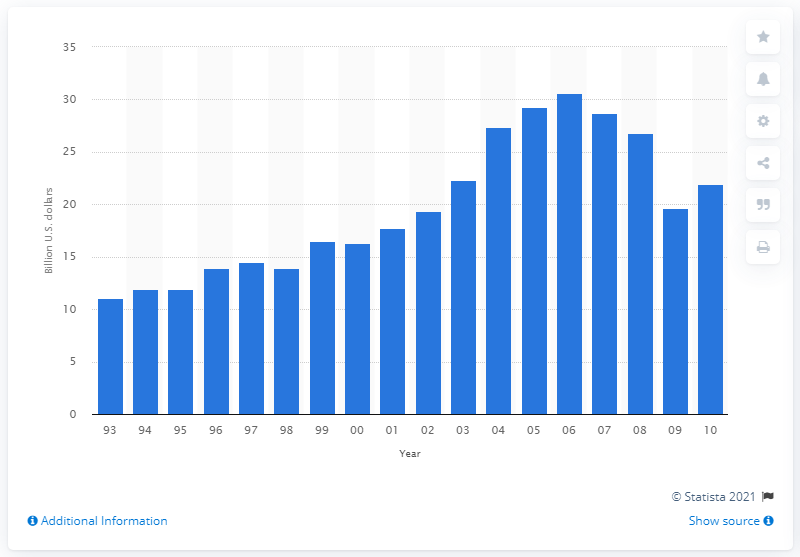Point out several critical features in this image. In 2005, the gross margin on lumber and other construction materials in U.S. wholesale was 29.3%. 